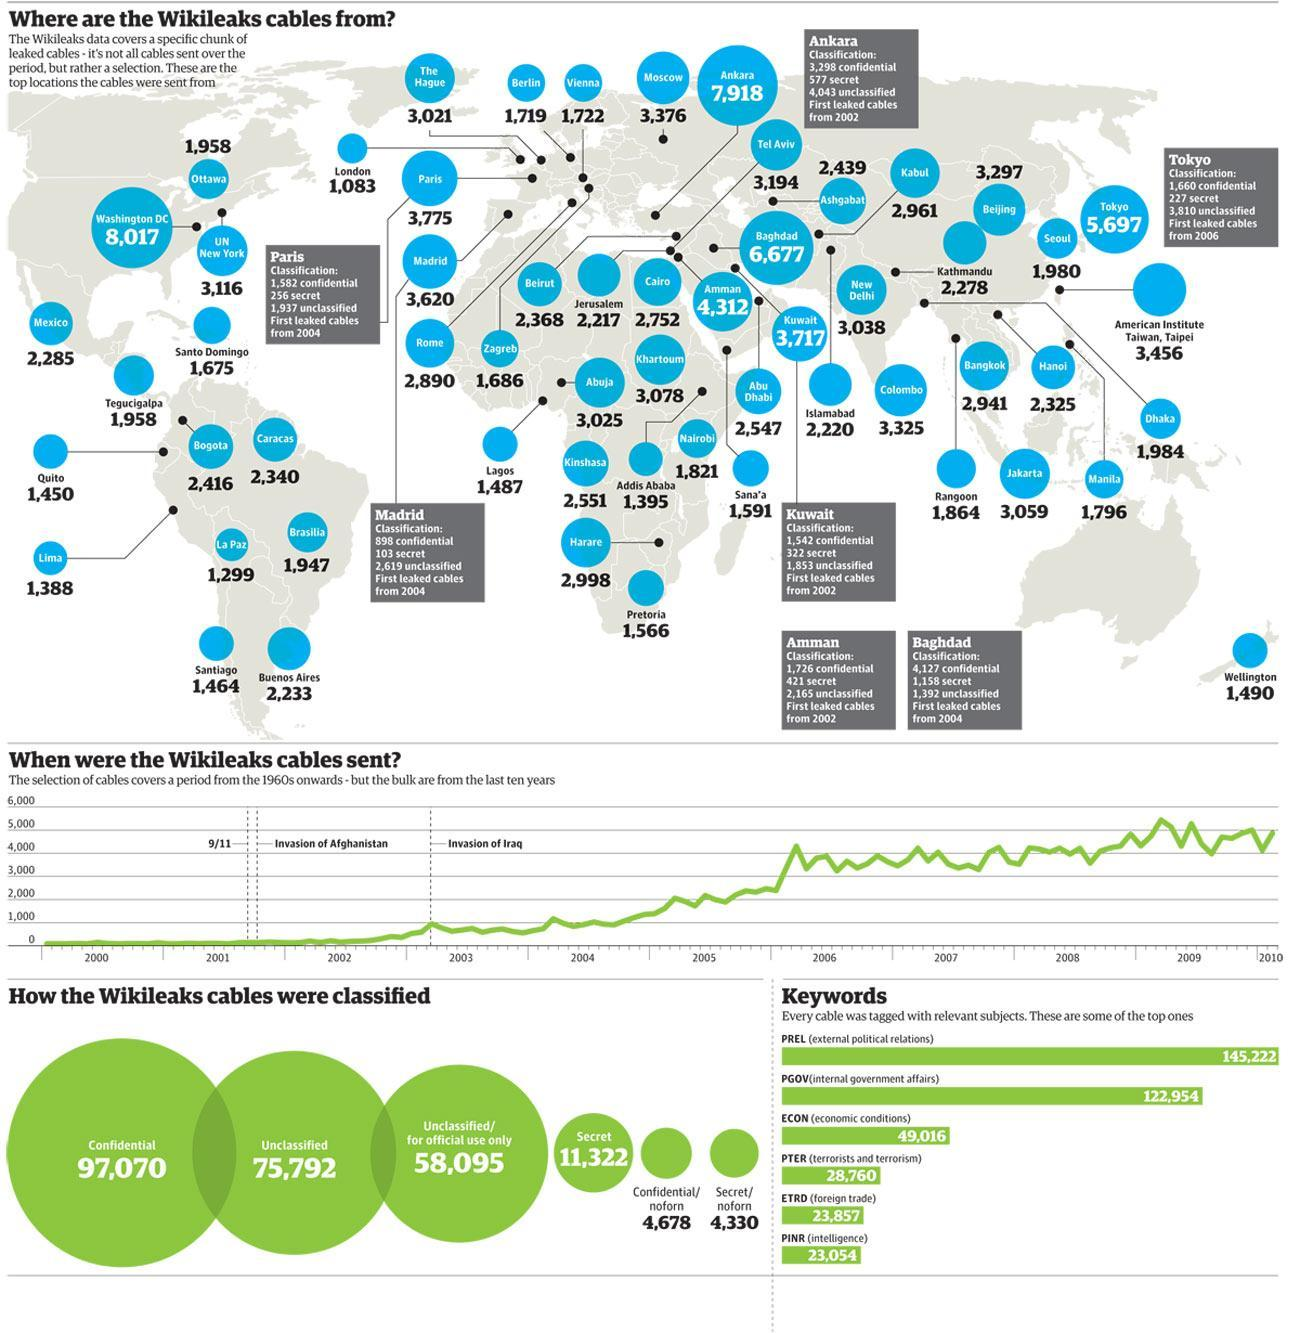How many leaked cables were tagged with ECON (economic conditions)?
Answer the question with a short phrase. 49,016 How many leaked cables in Madrid were classified as secret? 103 What is the total number of leaked cables from Cairo? 2,752 How many leaked cables were tagged with PGOV(internal government affairs)? 122,954 How many Wikileaks cables were classified as Confidential? 97,070 Which U.S. state has the highest number of Wikileaks cables? Washington DC How many leaked cables in Baghdad were classified as confidential? 4,127 Which is the major classification of Wikileaks cables across the world? Confidential What is the total number of leaked cables from Rome? 2,890 What is the number of Wikileaks cables classified as Secret? 11,322 